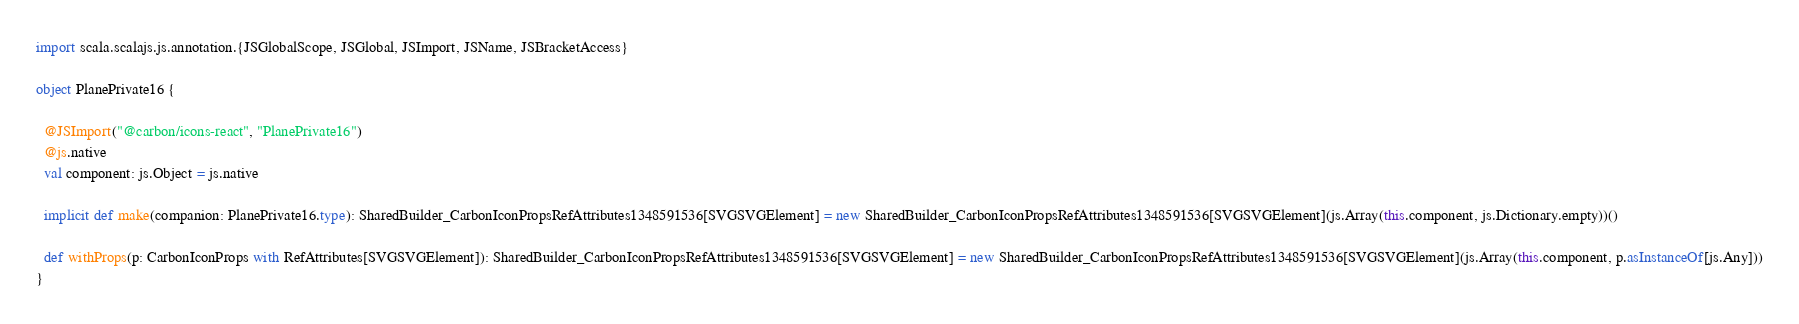<code> <loc_0><loc_0><loc_500><loc_500><_Scala_>import scala.scalajs.js.annotation.{JSGlobalScope, JSGlobal, JSImport, JSName, JSBracketAccess}

object PlanePrivate16 {
  
  @JSImport("@carbon/icons-react", "PlanePrivate16")
  @js.native
  val component: js.Object = js.native
  
  implicit def make(companion: PlanePrivate16.type): SharedBuilder_CarbonIconPropsRefAttributes1348591536[SVGSVGElement] = new SharedBuilder_CarbonIconPropsRefAttributes1348591536[SVGSVGElement](js.Array(this.component, js.Dictionary.empty))()
  
  def withProps(p: CarbonIconProps with RefAttributes[SVGSVGElement]): SharedBuilder_CarbonIconPropsRefAttributes1348591536[SVGSVGElement] = new SharedBuilder_CarbonIconPropsRefAttributes1348591536[SVGSVGElement](js.Array(this.component, p.asInstanceOf[js.Any]))
}
</code> 